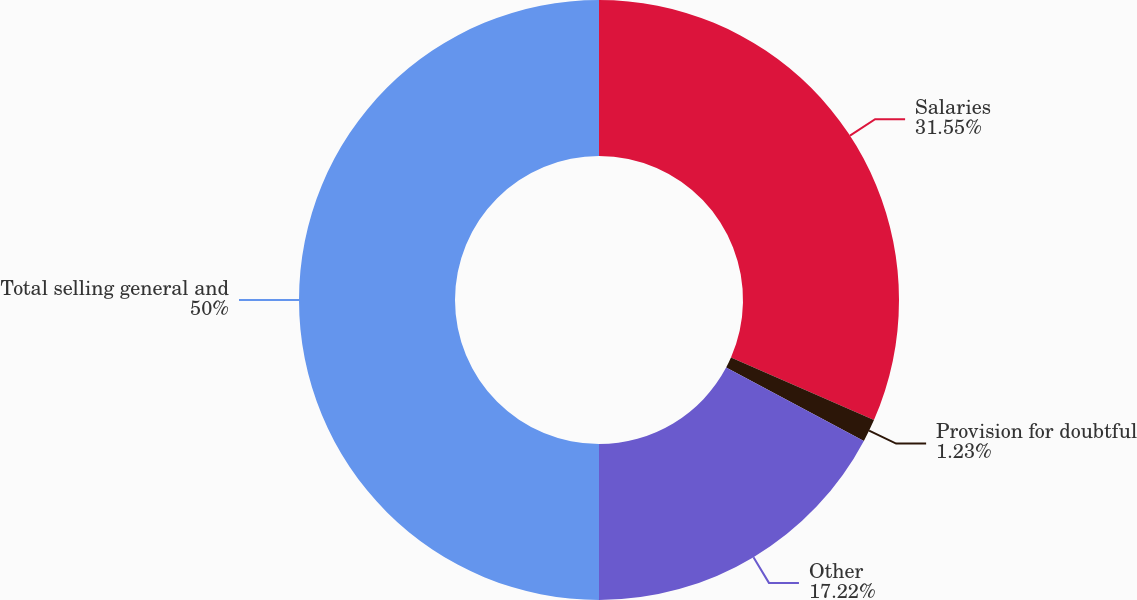Convert chart. <chart><loc_0><loc_0><loc_500><loc_500><pie_chart><fcel>Salaries<fcel>Provision for doubtful<fcel>Other<fcel>Total selling general and<nl><fcel>31.55%<fcel>1.23%<fcel>17.22%<fcel>50.0%<nl></chart> 